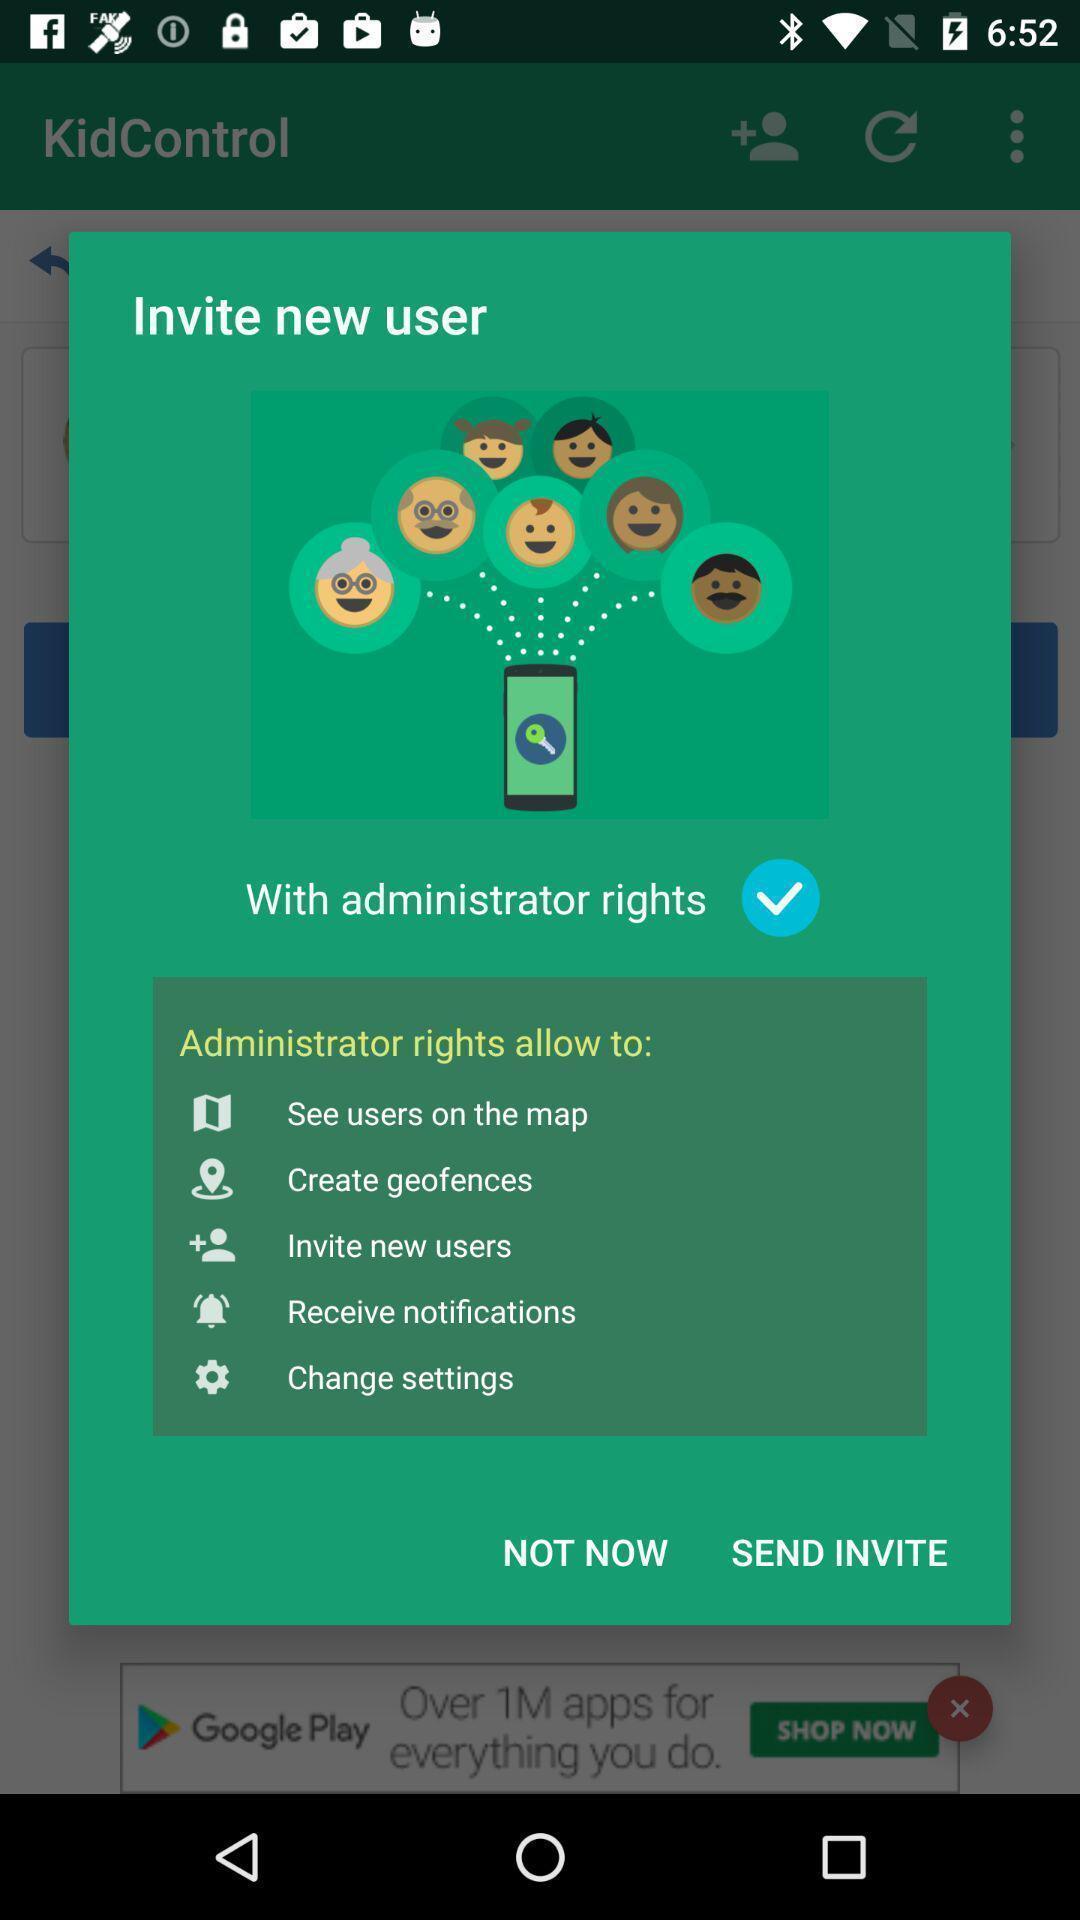Provide a description of this screenshot. Popup showing information about rights. 